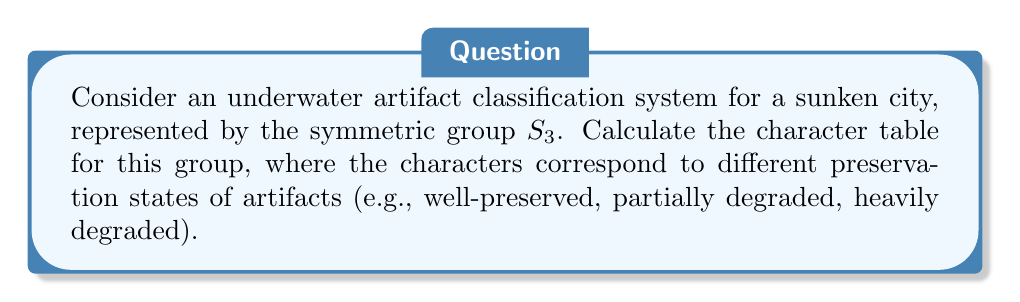Give your solution to this math problem. To calculate the character table for $S_3$, we'll follow these steps:

1. Identify the conjugacy classes of $S_3$:
   - $C_1 = \{e\}$ (identity)
   - $C_2 = \{(12), (13), (23)\}$ (transpositions)
   - $C_3 = \{(123), (132)\}$ (3-cycles)

2. Determine the irreducible representations:
   - Trivial representation: $\chi_1$
   - Sign representation: $\chi_2$
   - 2-dimensional representation: $\chi_3$

3. Calculate the characters for each representation:

   a) Trivial representation $\chi_1$:
      - $\chi_1(C_1) = 1$
      - $\chi_1(C_2) = 1$
      - $\chi_1(C_3) = 1$

   b) Sign representation $\chi_2$:
      - $\chi_2(C_1) = 1$
      - $\chi_2(C_2) = -1$
      - $\chi_2(C_3) = 1$

   c) 2-dimensional representation $\chi_3$:
      - $\chi_3(C_1) = 2$
      - $\chi_3(C_2) = 0$
      - $\chi_3(C_3) = -1$

4. Construct the character table:

   $$
   \begin{array}{c|ccc}
   S_3 & C_1 & C_2 & C_3 \\
   \hline
   \chi_1 & 1 & 1 & 1 \\
   \chi_2 & 1 & -1 & 1 \\
   \chi_3 & 2 & 0 & -1
   \end{array}
   $$

This character table represents how the different preservation states of artifacts (well-preserved, partially degraded, heavily degraded) transform under the classification system operations.
Answer: $$
\begin{array}{c|ccc}
S_3 & C_1 & C_2 & C_3 \\
\hline
\chi_1 & 1 & 1 & 1 \\
\chi_2 & 1 & -1 & 1 \\
\chi_3 & 2 & 0 & -1
\end{array}
$$ 